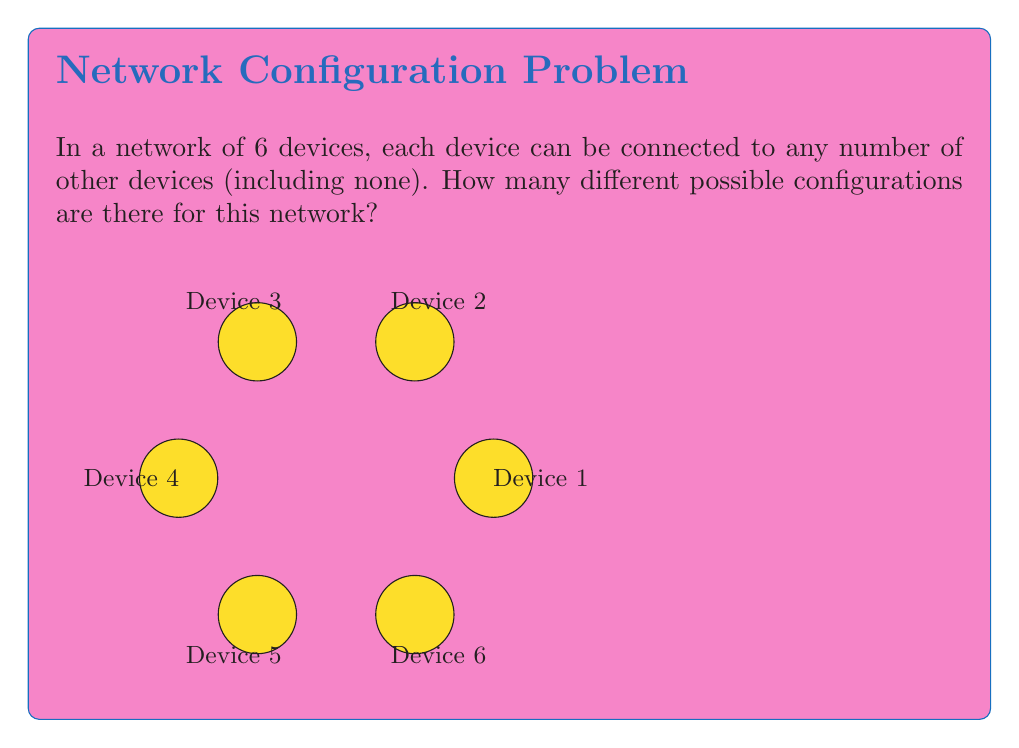Can you solve this math problem? Let's approach this step-by-step:

1) First, we need to understand what determines a configuration. For each pair of devices, we have two options: they are either connected or not connected.

2) In a network with 6 devices, we have $\binom{6}{2} = 15$ possible connections (edges between the devices).

3) For each of these 15 possible connections, we have 2 choices: the connection exists (1) or it doesn't (0).

4) This scenario is equivalent to a binary string of length 15, where each bit represents the presence (1) or absence (0) of a connection.

5) The number of possible binary strings of length 15 is $2^{15}$.

6) Therefore, the total number of possible configurations is $2^{15}$.

7) We can calculate this:

   $$2^{15} = 32,768$$

This approach uses the fundamental counting principle, where we multiply the number of choices for each independent decision (in this case, 2 choices for each of the 15 possible connections).
Answer: $2^{15} = 32,768$ 